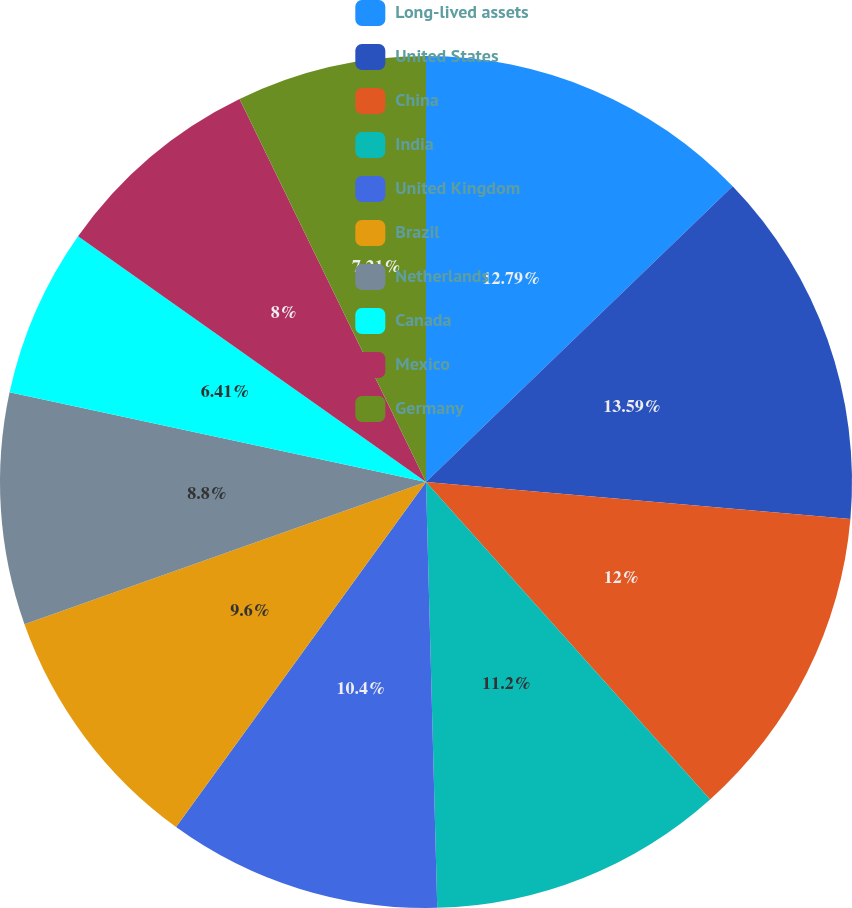Convert chart. <chart><loc_0><loc_0><loc_500><loc_500><pie_chart><fcel>Long-lived assets<fcel>United States<fcel>China<fcel>India<fcel>United Kingdom<fcel>Brazil<fcel>Netherlands<fcel>Canada<fcel>Mexico<fcel>Germany<nl><fcel>12.79%<fcel>13.59%<fcel>12.0%<fcel>11.2%<fcel>10.4%<fcel>9.6%<fcel>8.8%<fcel>6.41%<fcel>8.0%<fcel>7.21%<nl></chart> 